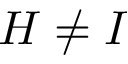Convert formula to latex. <formula><loc_0><loc_0><loc_500><loc_500>{ H \neq I }</formula> 